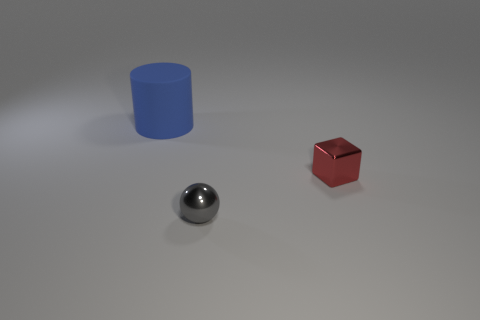Add 2 large purple matte cylinders. How many objects exist? 5 Subtract all blocks. How many objects are left? 2 Add 1 shiny balls. How many shiny balls exist? 2 Subtract 0 brown cylinders. How many objects are left? 3 Subtract all small spheres. Subtract all blue objects. How many objects are left? 1 Add 3 cylinders. How many cylinders are left? 4 